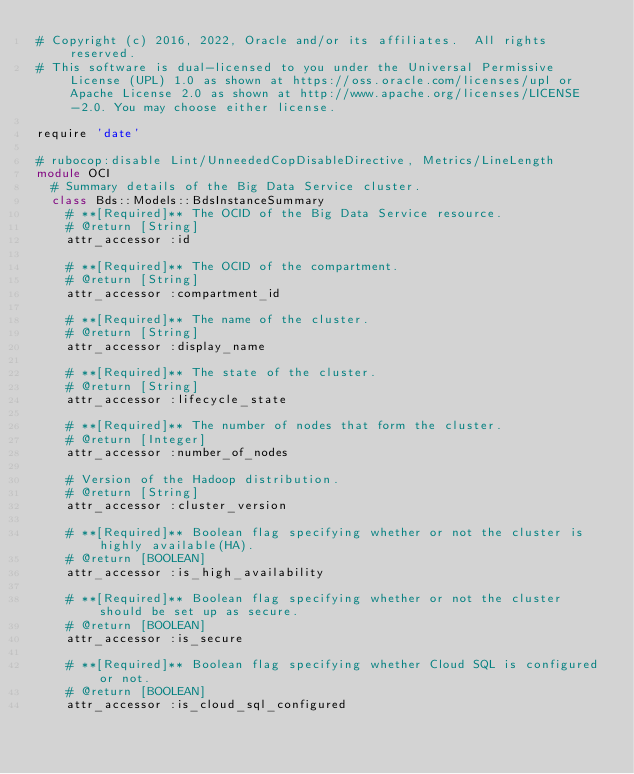Convert code to text. <code><loc_0><loc_0><loc_500><loc_500><_Ruby_># Copyright (c) 2016, 2022, Oracle and/or its affiliates.  All rights reserved.
# This software is dual-licensed to you under the Universal Permissive License (UPL) 1.0 as shown at https://oss.oracle.com/licenses/upl or Apache License 2.0 as shown at http://www.apache.org/licenses/LICENSE-2.0. You may choose either license.

require 'date'

# rubocop:disable Lint/UnneededCopDisableDirective, Metrics/LineLength
module OCI
  # Summary details of the Big Data Service cluster.
  class Bds::Models::BdsInstanceSummary
    # **[Required]** The OCID of the Big Data Service resource.
    # @return [String]
    attr_accessor :id

    # **[Required]** The OCID of the compartment.
    # @return [String]
    attr_accessor :compartment_id

    # **[Required]** The name of the cluster.
    # @return [String]
    attr_accessor :display_name

    # **[Required]** The state of the cluster.
    # @return [String]
    attr_accessor :lifecycle_state

    # **[Required]** The number of nodes that form the cluster.
    # @return [Integer]
    attr_accessor :number_of_nodes

    # Version of the Hadoop distribution.
    # @return [String]
    attr_accessor :cluster_version

    # **[Required]** Boolean flag specifying whether or not the cluster is highly available(HA).
    # @return [BOOLEAN]
    attr_accessor :is_high_availability

    # **[Required]** Boolean flag specifying whether or not the cluster should be set up as secure.
    # @return [BOOLEAN]
    attr_accessor :is_secure

    # **[Required]** Boolean flag specifying whether Cloud SQL is configured or not.
    # @return [BOOLEAN]
    attr_accessor :is_cloud_sql_configured
</code> 